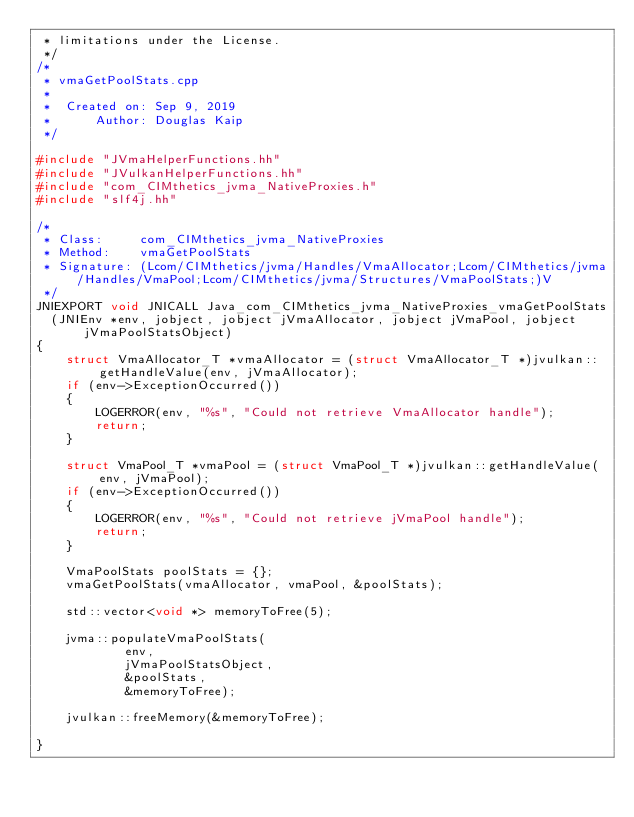Convert code to text. <code><loc_0><loc_0><loc_500><loc_500><_C++_> * limitations under the License.
 */
/*
 * vmaGetPoolStats.cpp
 *
 *  Created on: Sep 9, 2019
 *      Author: Douglas Kaip
 */

#include "JVmaHelperFunctions.hh"
#include "JVulkanHelperFunctions.hh"
#include "com_CIMthetics_jvma_NativeProxies.h"
#include "slf4j.hh"

/*
 * Class:     com_CIMthetics_jvma_NativeProxies
 * Method:    vmaGetPoolStats
 * Signature: (Lcom/CIMthetics/jvma/Handles/VmaAllocator;Lcom/CIMthetics/jvma/Handles/VmaPool;Lcom/CIMthetics/jvma/Structures/VmaPoolStats;)V
 */
JNIEXPORT void JNICALL Java_com_CIMthetics_jvma_NativeProxies_vmaGetPoolStats
  (JNIEnv *env, jobject, jobject jVmaAllocator, jobject jVmaPool, jobject jVmaPoolStatsObject)
{
    struct VmaAllocator_T *vmaAllocator = (struct VmaAllocator_T *)jvulkan::getHandleValue(env, jVmaAllocator);
    if (env->ExceptionOccurred())
    {
        LOGERROR(env, "%s", "Could not retrieve VmaAllocator handle");
        return;
    }

    struct VmaPool_T *vmaPool = (struct VmaPool_T *)jvulkan::getHandleValue(env, jVmaPool);
    if (env->ExceptionOccurred())
    {
        LOGERROR(env, "%s", "Could not retrieve jVmaPool handle");
        return;
    }

    VmaPoolStats poolStats = {};
    vmaGetPoolStats(vmaAllocator, vmaPool, &poolStats);

    std::vector<void *> memoryToFree(5);

    jvma::populateVmaPoolStats(
            env,
            jVmaPoolStatsObject,
            &poolStats,
            &memoryToFree);

    jvulkan::freeMemory(&memoryToFree);

}
</code> 